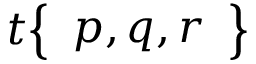Convert formula to latex. <formula><loc_0><loc_0><loc_500><loc_500>t { \left \{ \begin{array} { l } { p , q , r } \end{array} \right \} }</formula> 